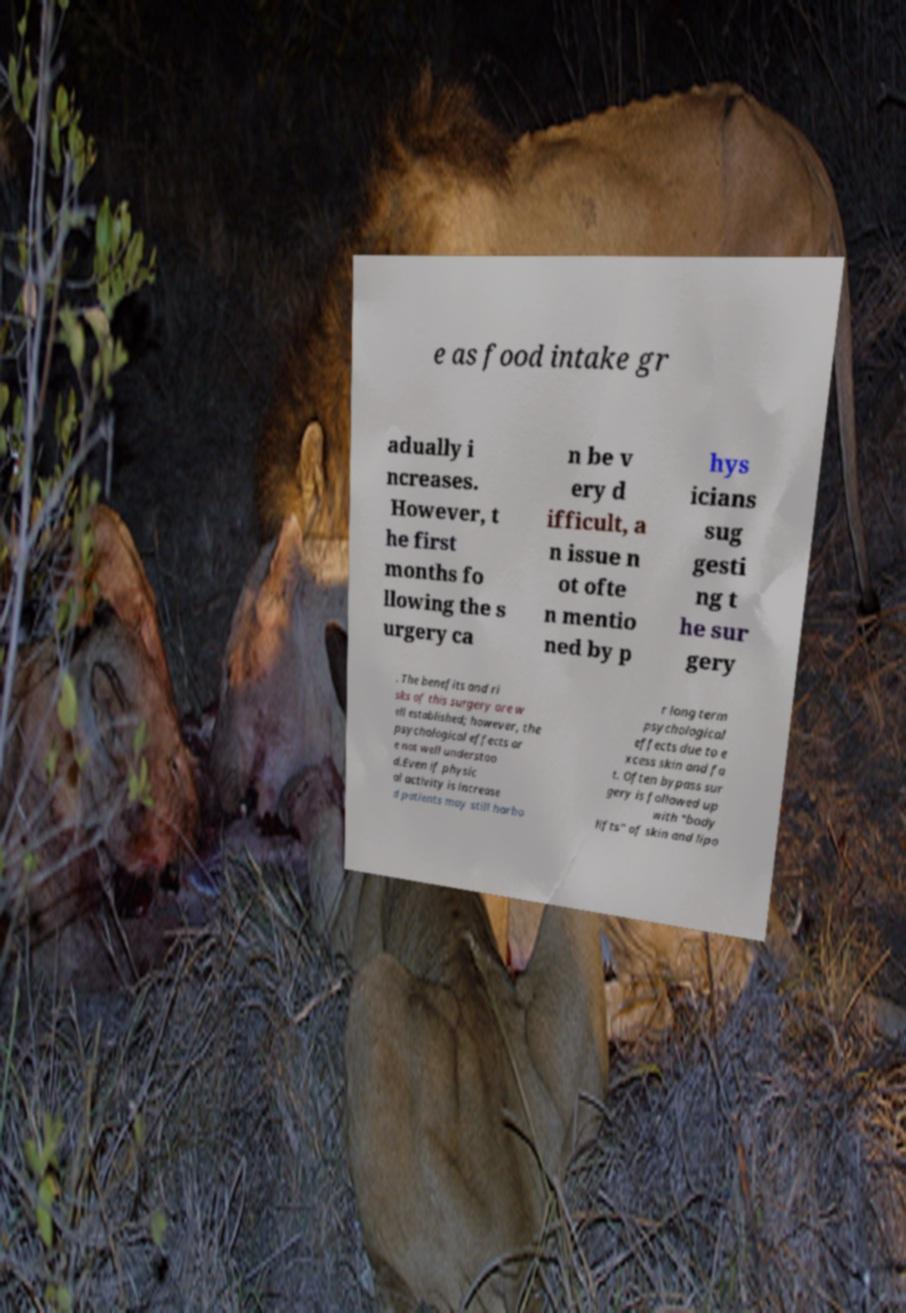I need the written content from this picture converted into text. Can you do that? e as food intake gr adually i ncreases. However, t he first months fo llowing the s urgery ca n be v ery d ifficult, a n issue n ot ofte n mentio ned by p hys icians sug gesti ng t he sur gery . The benefits and ri sks of this surgery are w ell established; however, the psychological effects ar e not well understoo d.Even if physic al activity is increase d patients may still harbo r long term psychological effects due to e xcess skin and fa t. Often bypass sur gery is followed up with "body lifts" of skin and lipo 